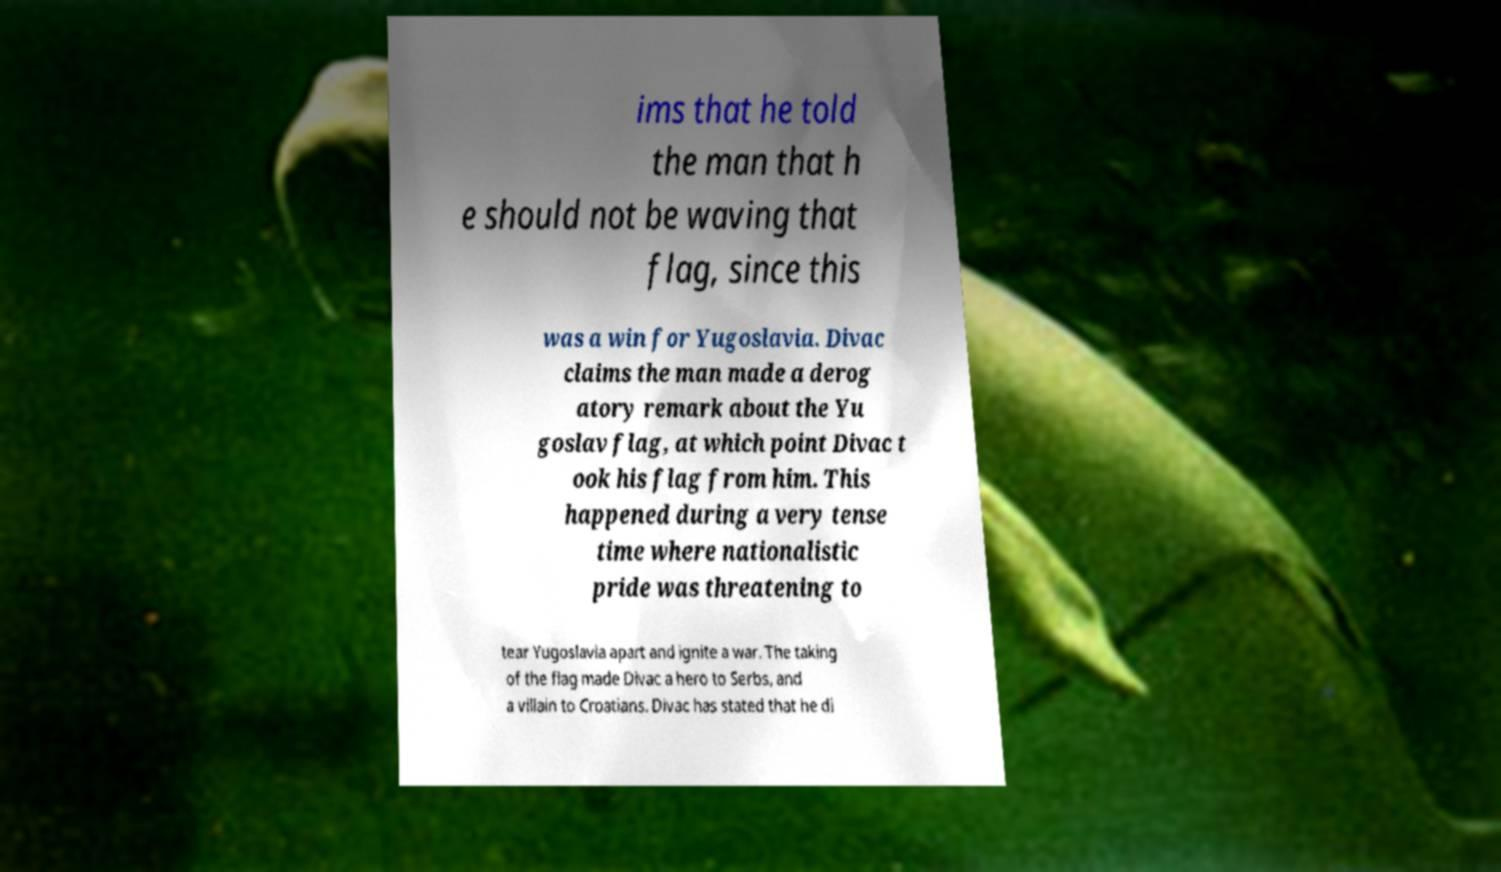Please identify and transcribe the text found in this image. ims that he told the man that h e should not be waving that flag, since this was a win for Yugoslavia. Divac claims the man made a derog atory remark about the Yu goslav flag, at which point Divac t ook his flag from him. This happened during a very tense time where nationalistic pride was threatening to tear Yugoslavia apart and ignite a war. The taking of the flag made Divac a hero to Serbs, and a villain to Croatians. Divac has stated that he di 